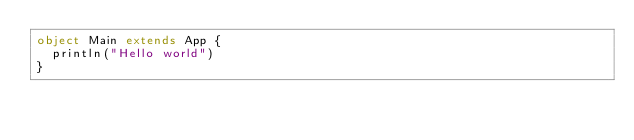<code> <loc_0><loc_0><loc_500><loc_500><_Scala_>object Main extends App {
  println("Hello world")
}
</code> 